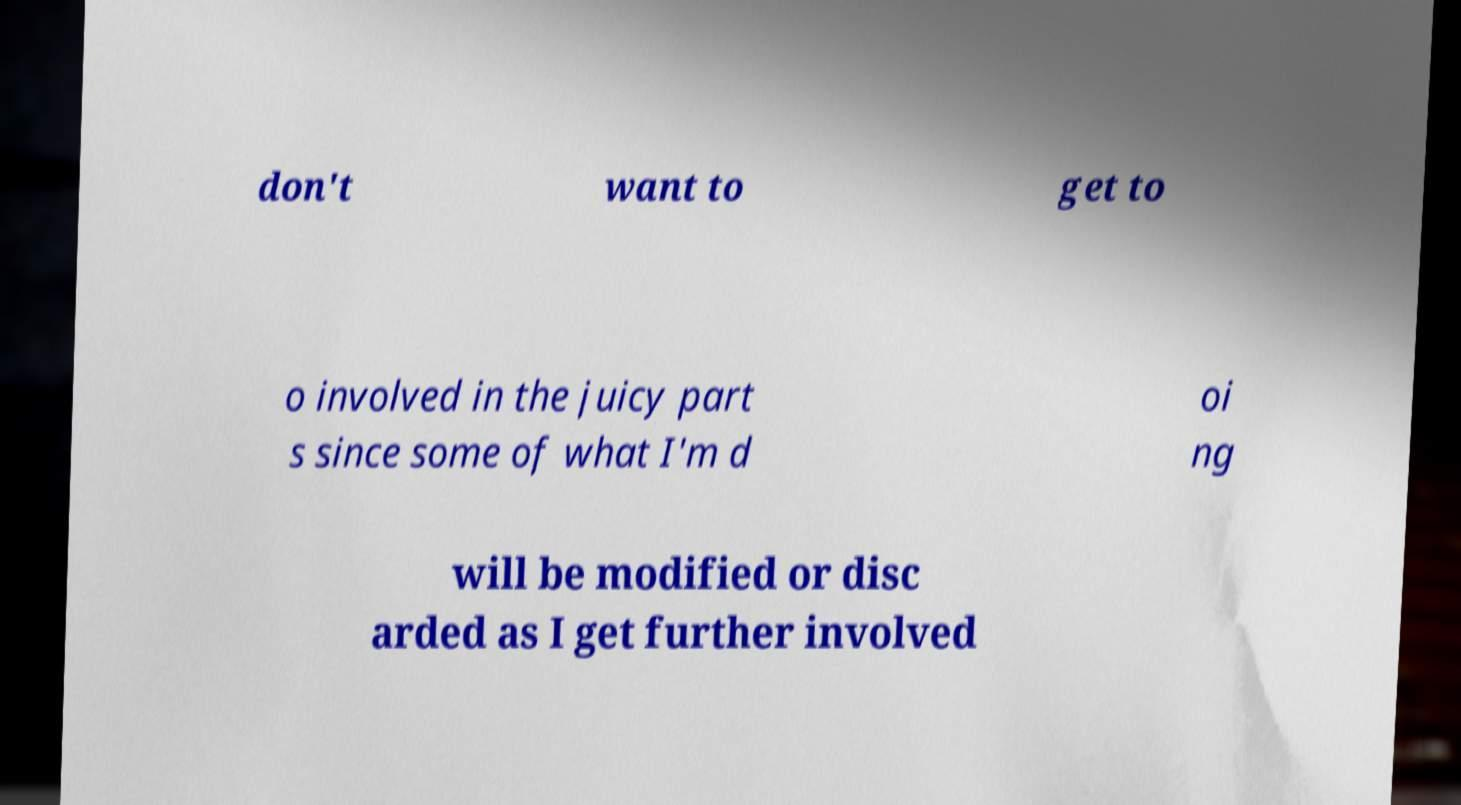Could you assist in decoding the text presented in this image and type it out clearly? don't want to get to o involved in the juicy part s since some of what I'm d oi ng will be modified or disc arded as I get further involved 